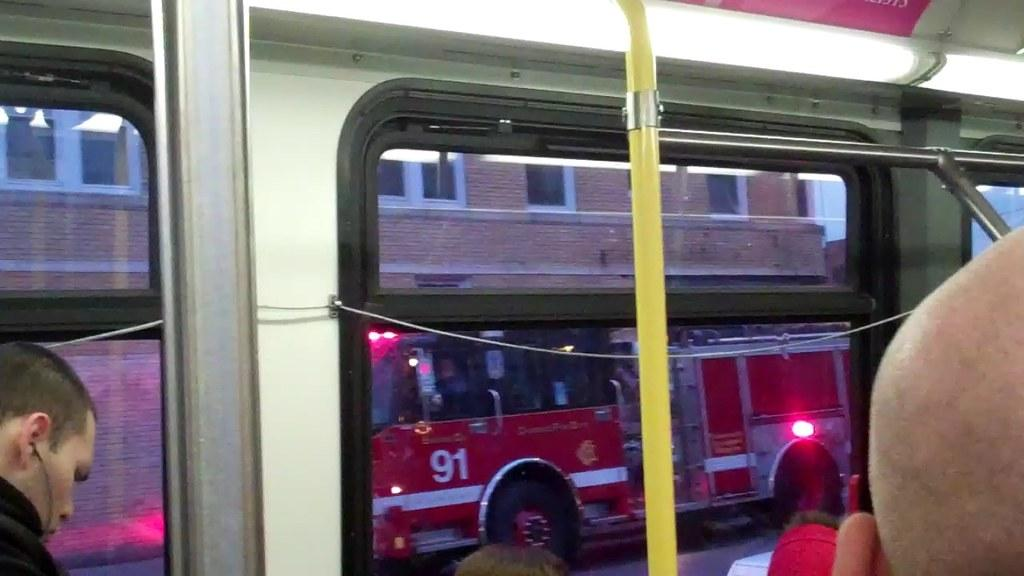What can be seen on the road in the image? There are vehicles on the road in the image. Are there any occupants in the vehicles? Yes, there are people inside the vehicles. What is visible in the background of the image? There is a building with windows in the background of the image. What season is being taught in the image? There is no indication of teaching or a specific season in the image. 